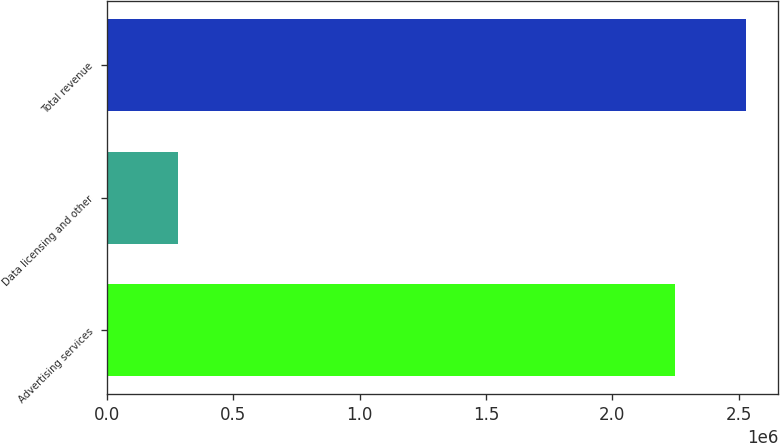Convert chart. <chart><loc_0><loc_0><loc_500><loc_500><bar_chart><fcel>Advertising services<fcel>Data licensing and other<fcel>Total revenue<nl><fcel>2.24805e+06<fcel>281567<fcel>2.52962e+06<nl></chart> 